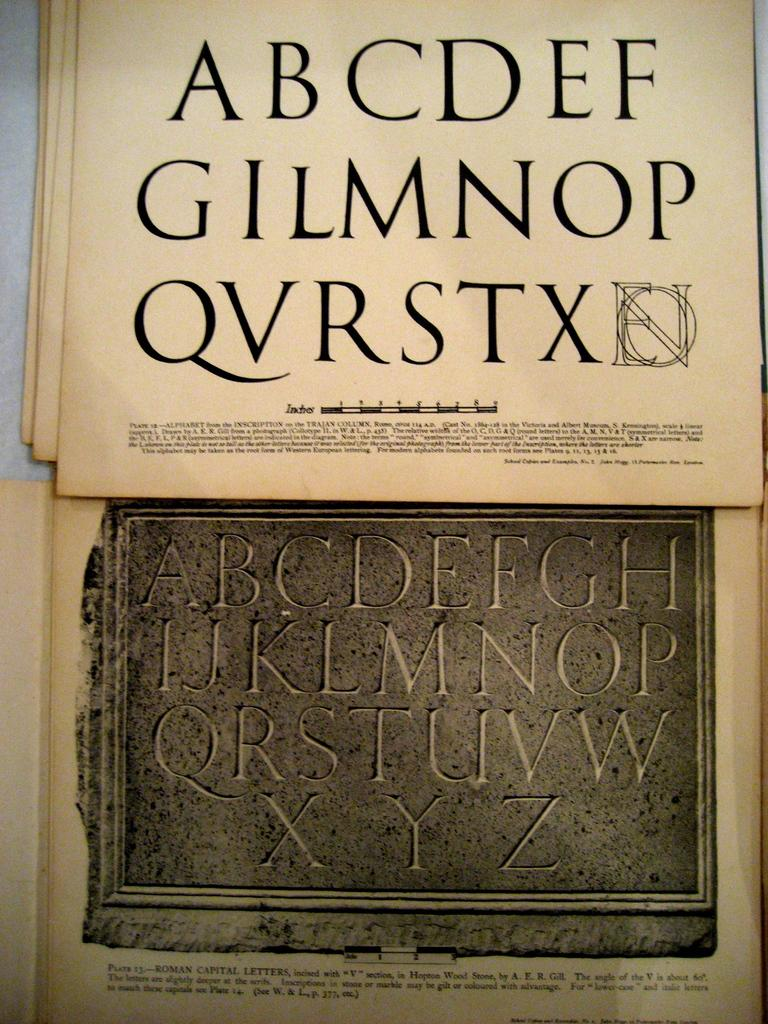<image>
Share a concise interpretation of the image provided. A sting of letters starting with A, B and C are printed on a paper. 